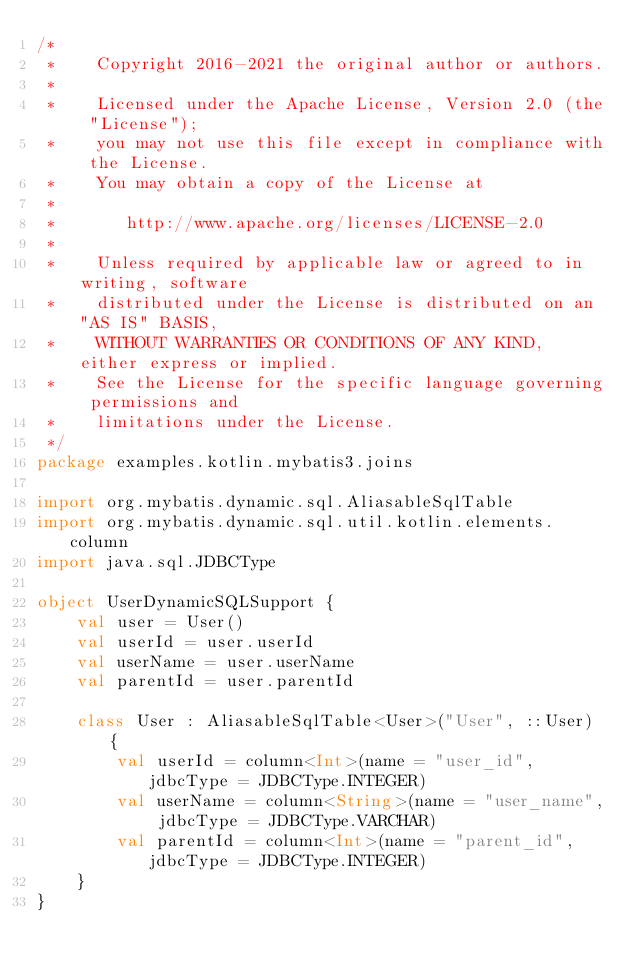<code> <loc_0><loc_0><loc_500><loc_500><_Kotlin_>/*
 *    Copyright 2016-2021 the original author or authors.
 *
 *    Licensed under the Apache License, Version 2.0 (the "License");
 *    you may not use this file except in compliance with the License.
 *    You may obtain a copy of the License at
 *
 *       http://www.apache.org/licenses/LICENSE-2.0
 *
 *    Unless required by applicable law or agreed to in writing, software
 *    distributed under the License is distributed on an "AS IS" BASIS,
 *    WITHOUT WARRANTIES OR CONDITIONS OF ANY KIND, either express or implied.
 *    See the License for the specific language governing permissions and
 *    limitations under the License.
 */
package examples.kotlin.mybatis3.joins

import org.mybatis.dynamic.sql.AliasableSqlTable
import org.mybatis.dynamic.sql.util.kotlin.elements.column
import java.sql.JDBCType

object UserDynamicSQLSupport {
    val user = User()
    val userId = user.userId
    val userName = user.userName
    val parentId = user.parentId

    class User : AliasableSqlTable<User>("User", ::User) {
        val userId = column<Int>(name = "user_id", jdbcType = JDBCType.INTEGER)
        val userName = column<String>(name = "user_name", jdbcType = JDBCType.VARCHAR)
        val parentId = column<Int>(name = "parent_id", jdbcType = JDBCType.INTEGER)
    }
}
</code> 